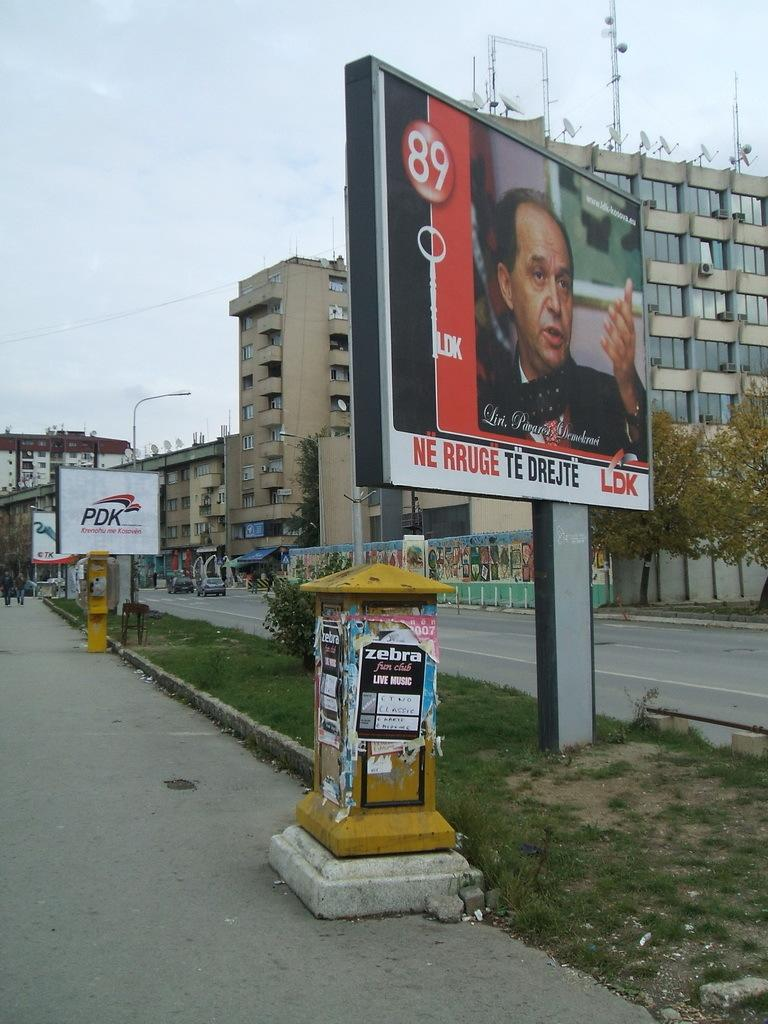<image>
Provide a brief description of the given image. The billboard shows a man and it says "NE RRUGE TE DREJTE". 